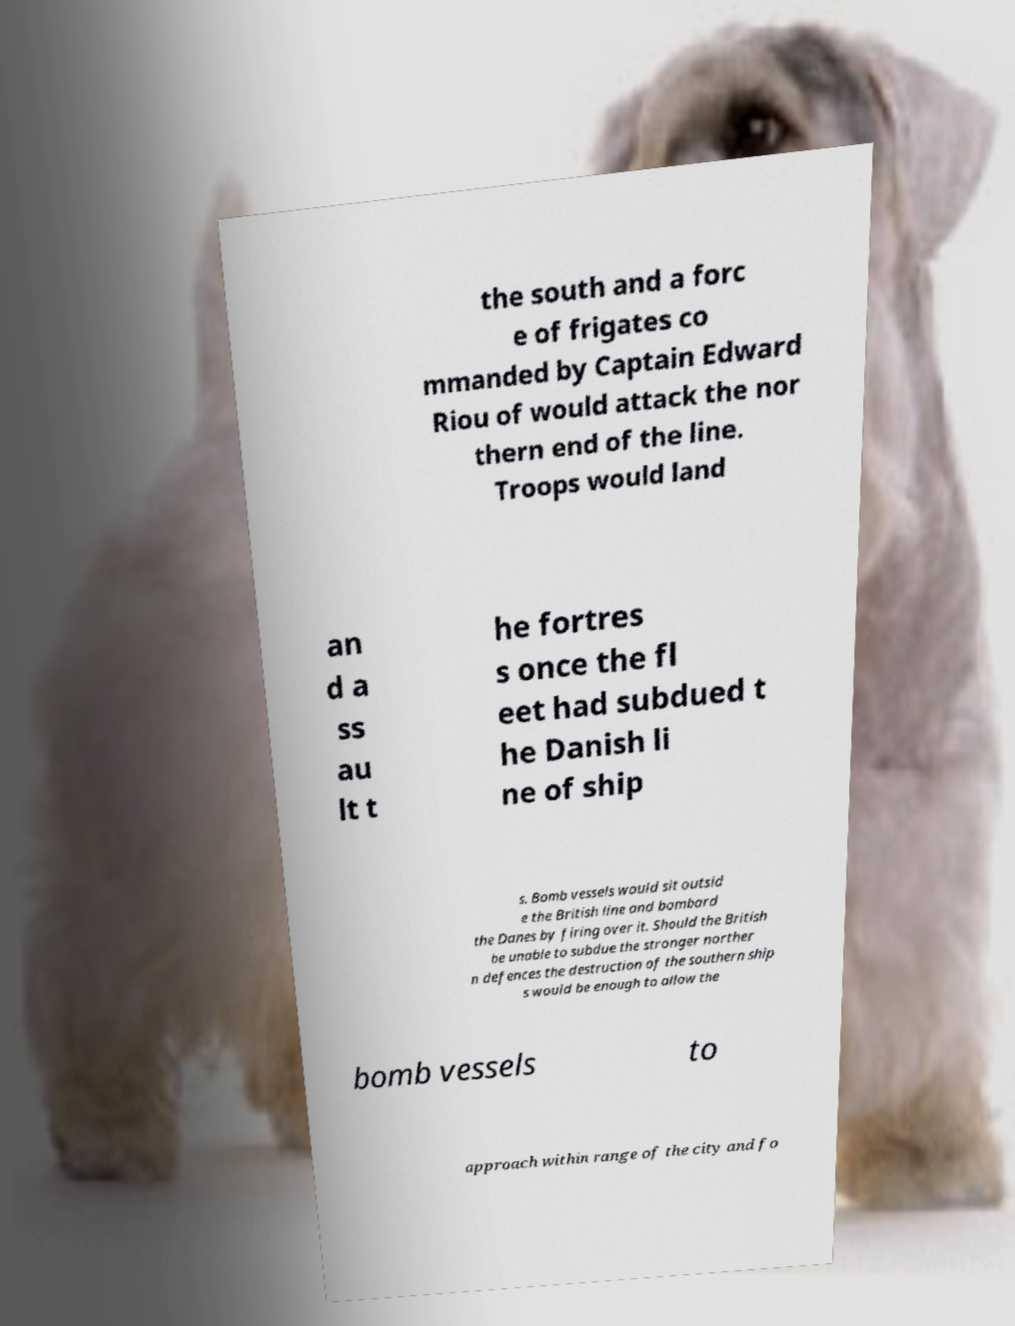There's text embedded in this image that I need extracted. Can you transcribe it verbatim? the south and a forc e of frigates co mmanded by Captain Edward Riou of would attack the nor thern end of the line. Troops would land an d a ss au lt t he fortres s once the fl eet had subdued t he Danish li ne of ship s. Bomb vessels would sit outsid e the British line and bombard the Danes by firing over it. Should the British be unable to subdue the stronger norther n defences the destruction of the southern ship s would be enough to allow the bomb vessels to approach within range of the city and fo 